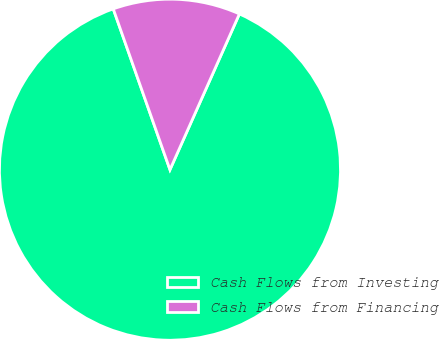Convert chart. <chart><loc_0><loc_0><loc_500><loc_500><pie_chart><fcel>Cash Flows from Investing<fcel>Cash Flows from Financing<nl><fcel>87.93%<fcel>12.07%<nl></chart> 